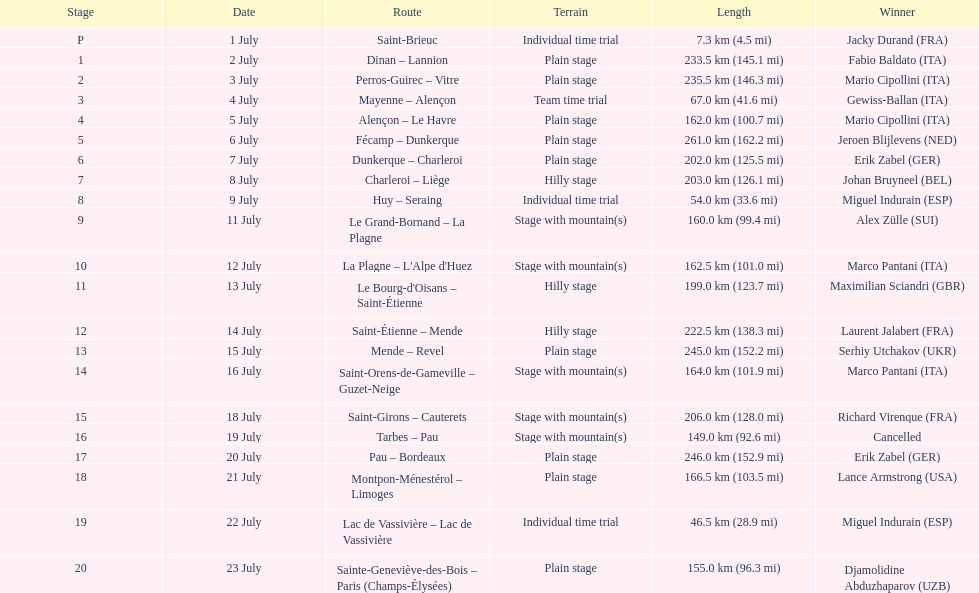What was the number of stages in the 1995 tour de france that were 200 km or longer? 9. 